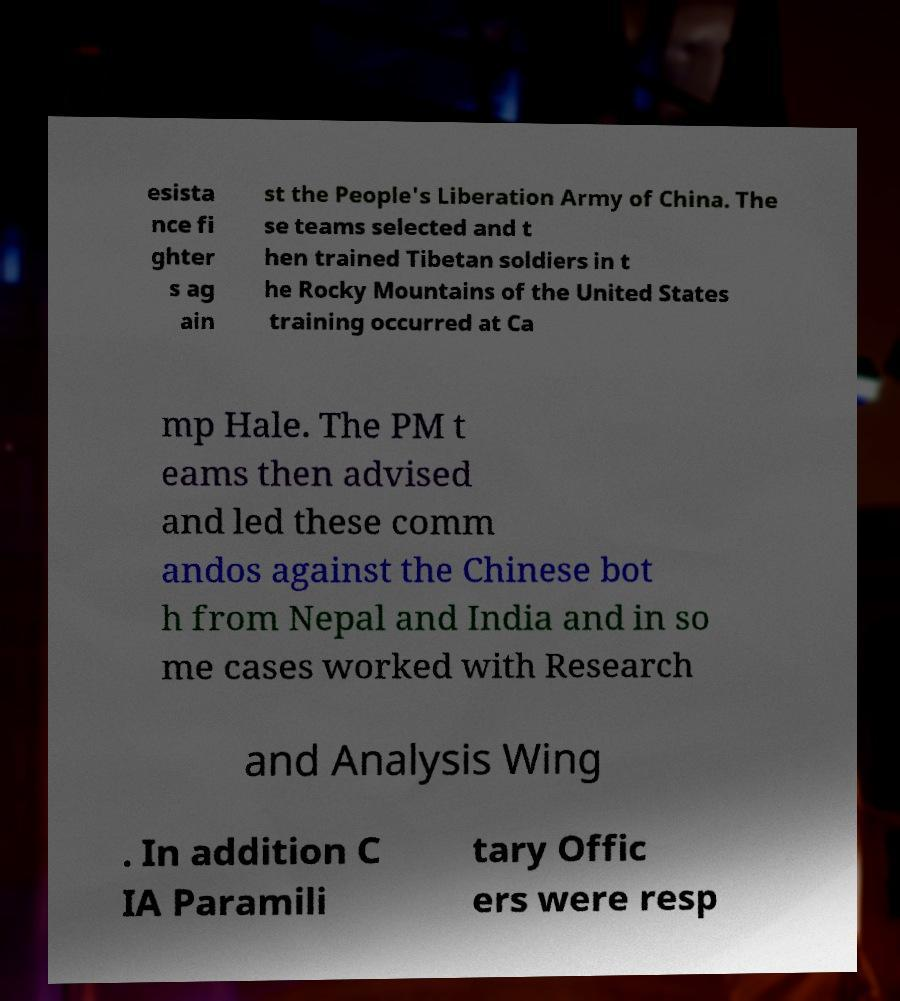Please read and relay the text visible in this image. What does it say? esista nce fi ghter s ag ain st the People's Liberation Army of China. The se teams selected and t hen trained Tibetan soldiers in t he Rocky Mountains of the United States training occurred at Ca mp Hale. The PM t eams then advised and led these comm andos against the Chinese bot h from Nepal and India and in so me cases worked with Research and Analysis Wing . In addition C IA Paramili tary Offic ers were resp 